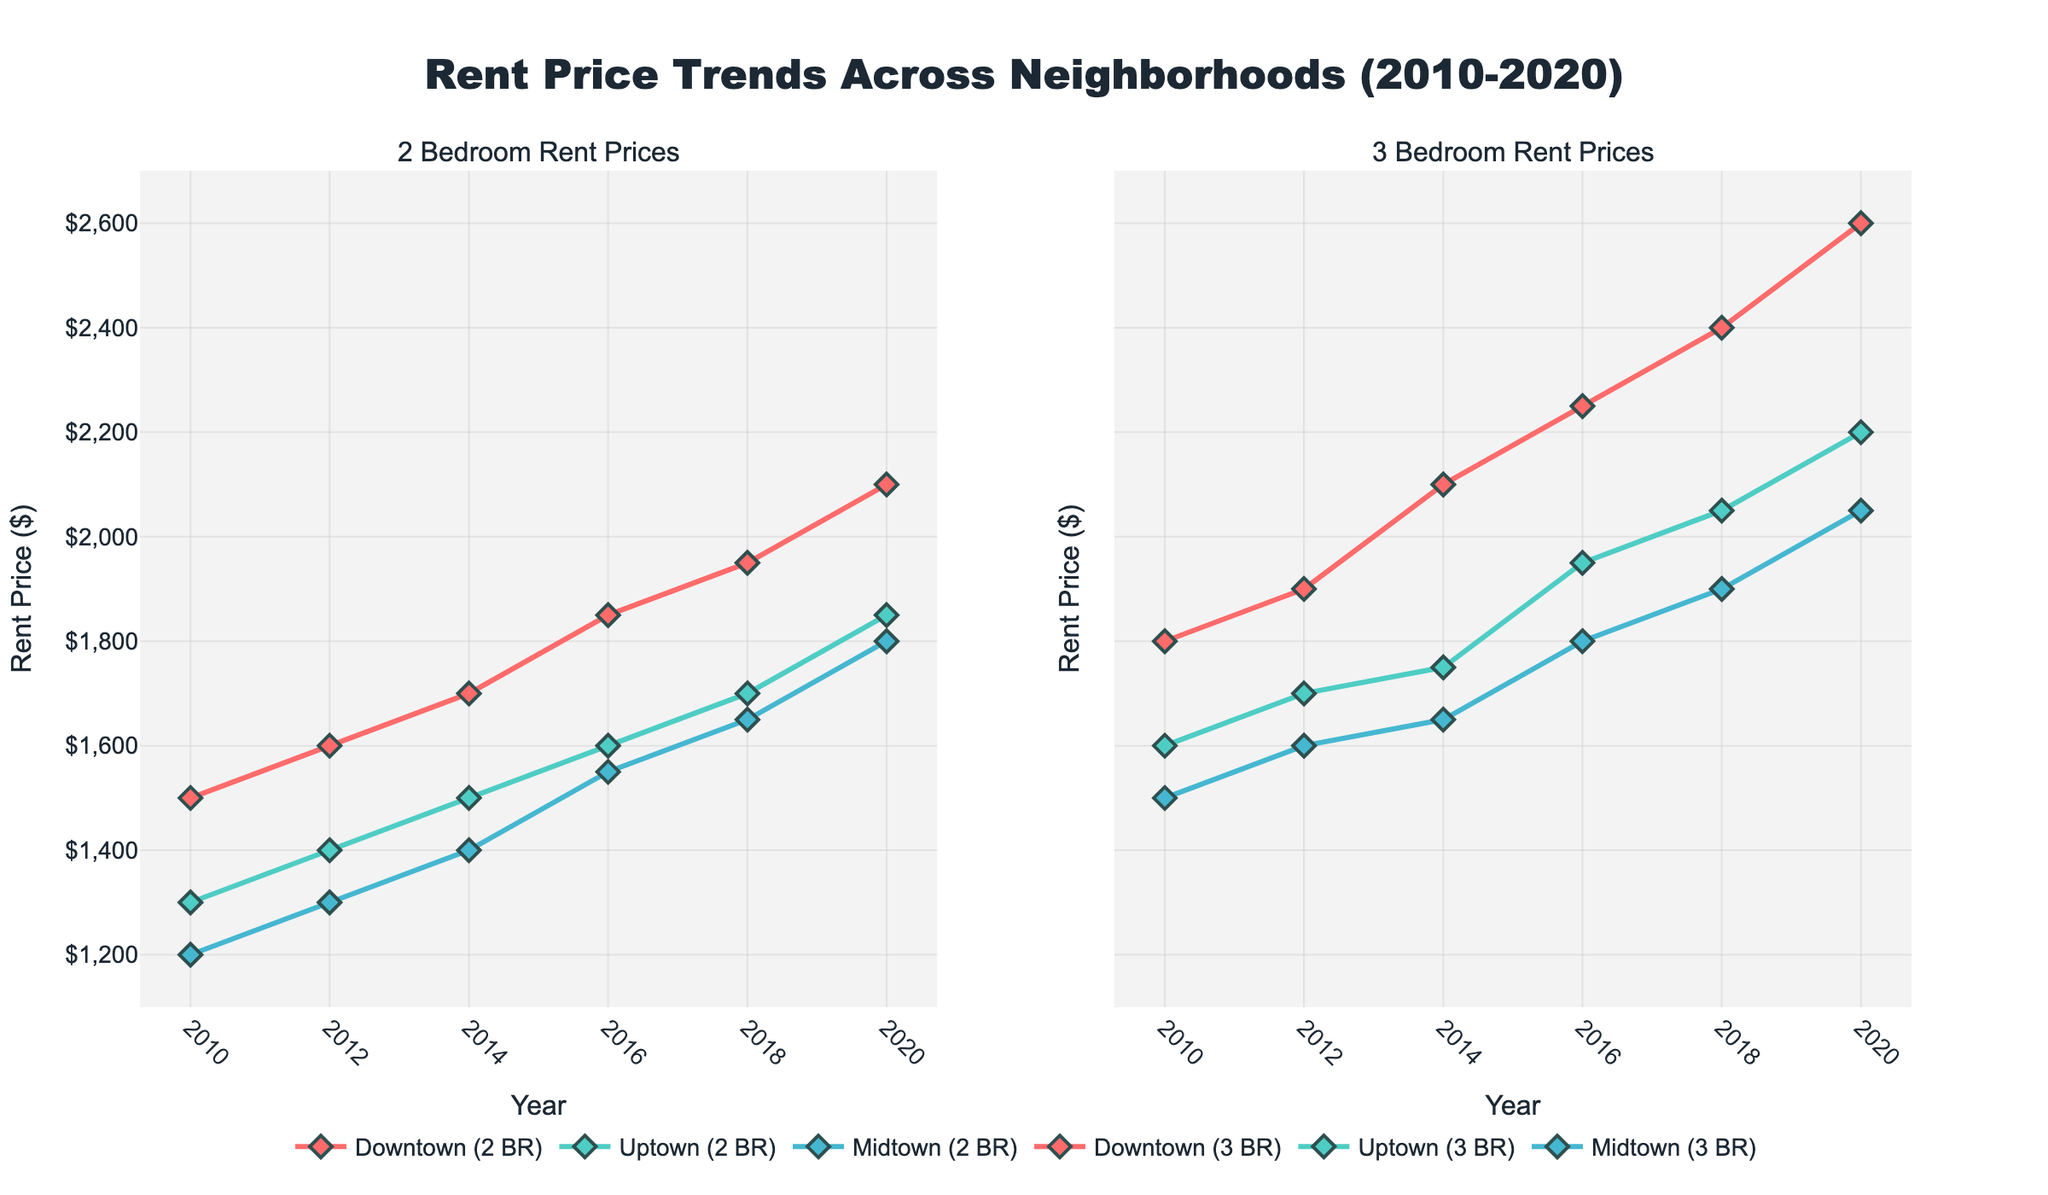What's the title of the figure? The title is generally found at the top and is often the largest text in the figure. It helps us understand the overall subject of the figure.
Answer: Rent Price Trends Across Neighborhoods (2010-2020) How many neighborhoods are shown in the plot? We can determine the number of neighborhoods by looking at the legend, which lists all the groups in the plot. Each neighborhood corresponds to a different color and line style.
Answer: 3 What is the rent price for a 2-bedroom apartment in Midtown in 2010? We look at the left subplot for 2 bedrooms and find the corresponding line and marker color for Midtown at the 2010 point on the x-axis.
Answer: $1200 Which neighborhood had the highest rent price for 3-bedroom apartments in 2018? We check the right subplot for 3 bedrooms and compare the lines for different neighborhoods at the 2018 mark on the x-axis.
Answer: Downtown How did the rent price for 2-bedroom apartments in Downtown change from 2010 to 2020? We need to identify the line and marker color for Downtown in the left subplot and observe the change in y-values from 2010 to 2020.
Answer: Increased from $1500 to $2100 What is the average rent price for 2-bedroom apartments in Uptown over the period? Calculate by adding the rent prices for Uptown's 2-bedroom apartments from all years and then dividing by the number of years to get the average.
Answer: (1300 + 1400 + 1500 + 1600 + 1700 + 1850) / 6 = $1550 Which neighborhood shows the least variability in rent prices for 3-bedroom apartments? We compare the fluctuations in the lines of each neighborhood in the right subplot. The neighborhood with the flattest line shows the least variability.
Answer: Midtown By how much did the rent price for a 3-bedroom apartment in Uptown increase between 2016 and 2020? The rent prices for 2016 and 2020 for Uptown's 3-bedroom apartments can be identified in the right subplot. Subtract the 2016 value from the 2020 value.
Answer: $2200 - $1950 = $250 Is there any year where the rent prices for 2-bedroom apartments were the same across all neighborhoods? Check the left subplot to see if there is any vertical alignment of markers with the same y-value for all neighborhoods at any point on the x-axis.
Answer: No Compare the trend of rent price increase between Downtown and Midtown for 3-bedroom apartments. In the right subplot, assess the overall slope and changes in y-values over time for Downtown and Midtown.
Answer: Downtown saw a steeper increase while Midtown had a more gradual rise 